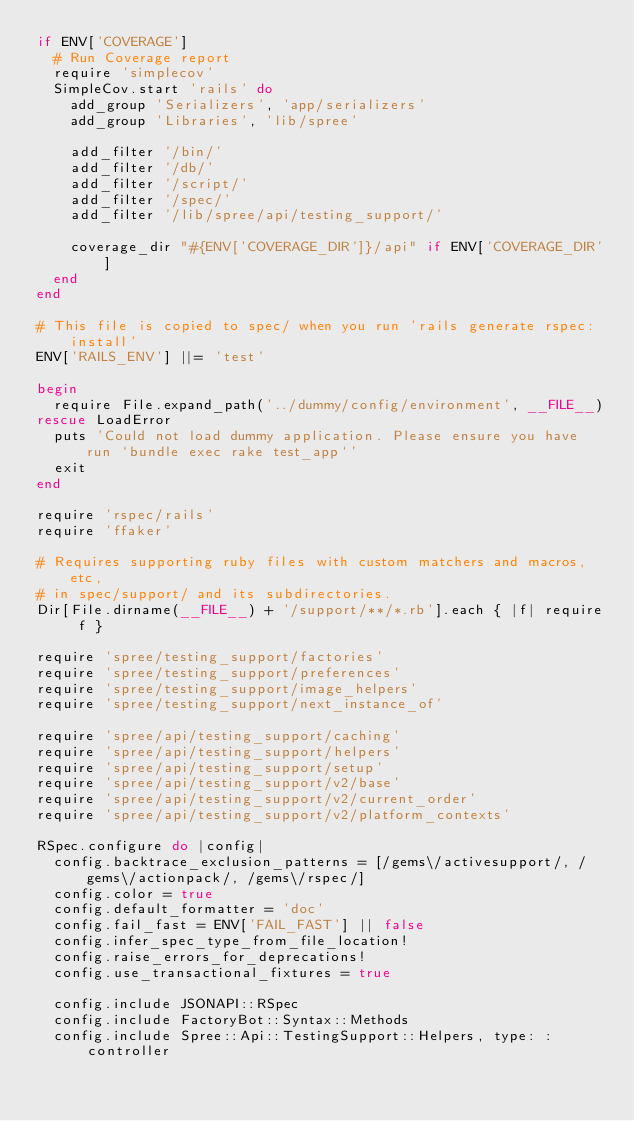<code> <loc_0><loc_0><loc_500><loc_500><_Ruby_>if ENV['COVERAGE']
  # Run Coverage report
  require 'simplecov'
  SimpleCov.start 'rails' do
    add_group 'Serializers', 'app/serializers'
    add_group 'Libraries', 'lib/spree'

    add_filter '/bin/'
    add_filter '/db/'
    add_filter '/script/'
    add_filter '/spec/'
    add_filter '/lib/spree/api/testing_support/'

    coverage_dir "#{ENV['COVERAGE_DIR']}/api" if ENV['COVERAGE_DIR']
  end
end

# This file is copied to spec/ when you run 'rails generate rspec:install'
ENV['RAILS_ENV'] ||= 'test'

begin
  require File.expand_path('../dummy/config/environment', __FILE__)
rescue LoadError
  puts 'Could not load dummy application. Please ensure you have run `bundle exec rake test_app`'
  exit
end

require 'rspec/rails'
require 'ffaker'

# Requires supporting ruby files with custom matchers and macros, etc,
# in spec/support/ and its subdirectories.
Dir[File.dirname(__FILE__) + '/support/**/*.rb'].each { |f| require f }

require 'spree/testing_support/factories'
require 'spree/testing_support/preferences'
require 'spree/testing_support/image_helpers'
require 'spree/testing_support/next_instance_of'

require 'spree/api/testing_support/caching'
require 'spree/api/testing_support/helpers'
require 'spree/api/testing_support/setup'
require 'spree/api/testing_support/v2/base'
require 'spree/api/testing_support/v2/current_order'
require 'spree/api/testing_support/v2/platform_contexts'

RSpec.configure do |config|
  config.backtrace_exclusion_patterns = [/gems\/activesupport/, /gems\/actionpack/, /gems\/rspec/]
  config.color = true
  config.default_formatter = 'doc'
  config.fail_fast = ENV['FAIL_FAST'] || false
  config.infer_spec_type_from_file_location!
  config.raise_errors_for_deprecations!
  config.use_transactional_fixtures = true

  config.include JSONAPI::RSpec
  config.include FactoryBot::Syntax::Methods
  config.include Spree::Api::TestingSupport::Helpers, type: :controller</code> 